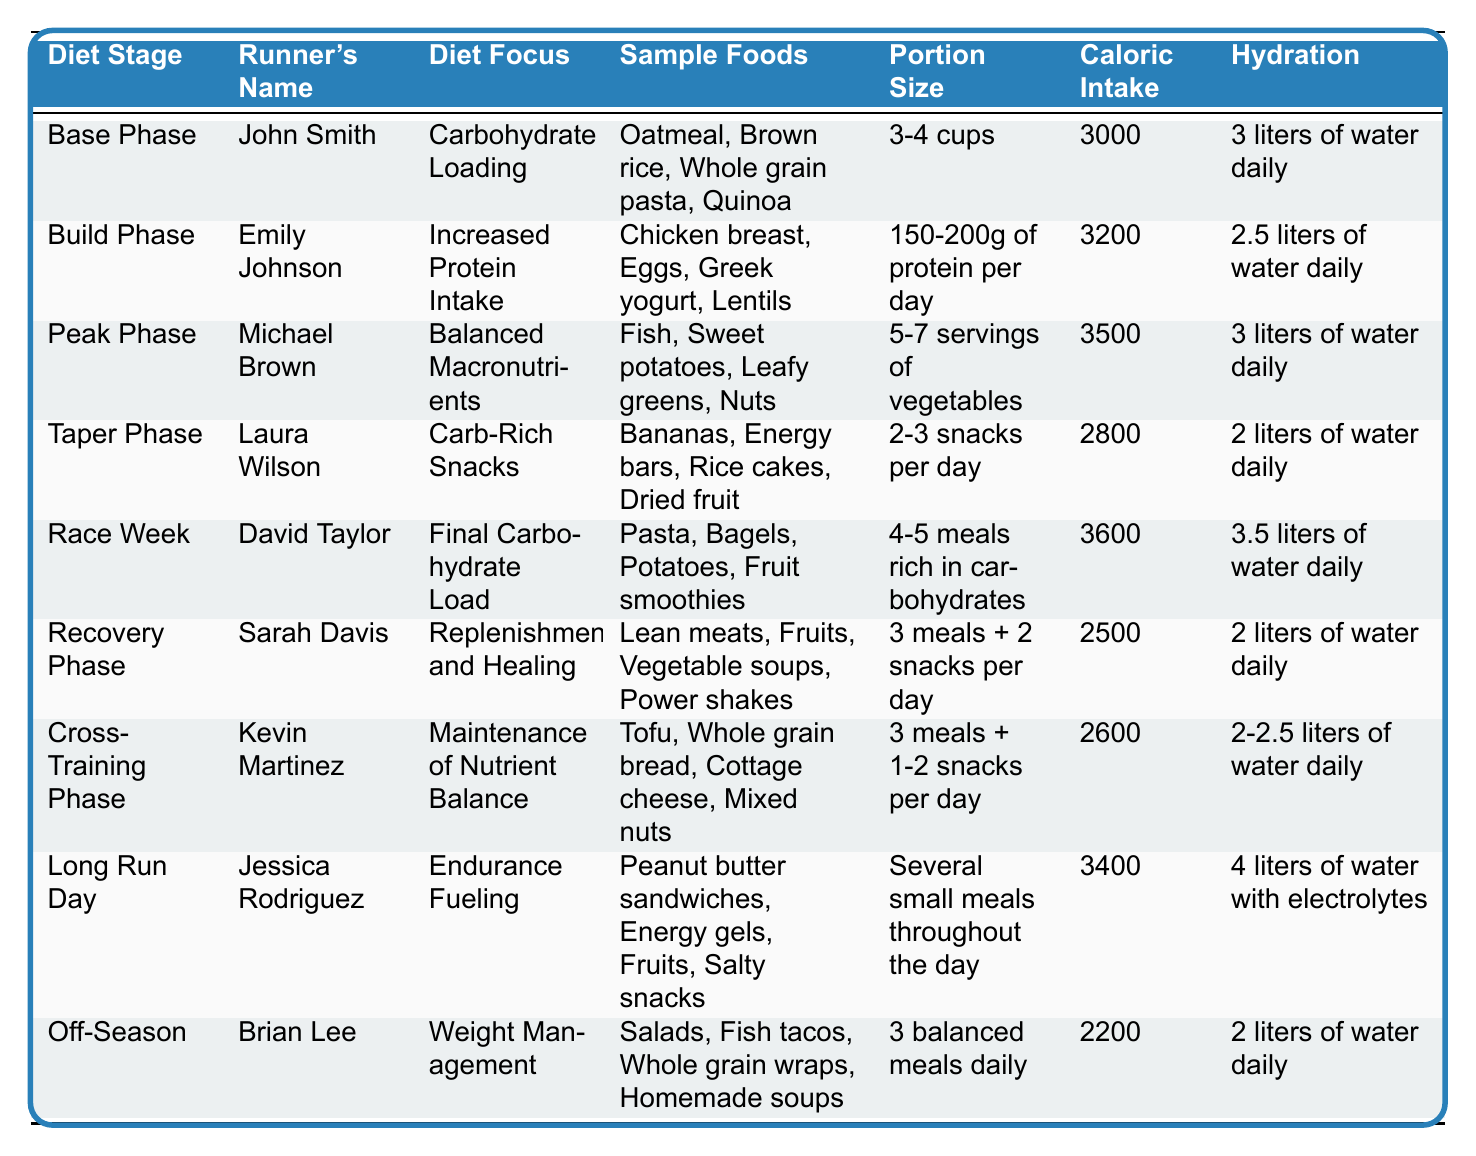What is the diet focus for John Smith during the Base Phase? In the table, under the "DietStage" of "Base Phase," the "DietFocus" listed for "John Smith" is "Carbohydrate Loading."
Answer: Carbohydrate Loading How many liters of water does Sarah Davis consume daily during the Recovery Phase? The table indicates that "Sarah Davis" consumes "2 liters of water daily" during the "Recovery Phase."
Answer: 2 liters What is the total caloric intake proposed for the Peak Phase? Under "Peak Phase," the table shows a "Caloric Intake" of 3500 calories.
Answer: 3500 calories Which runner focuses on maintenance of nutrient balance? The table shows that "Kevin Martinez" is in the "Cross-Training Phase," focusing on "Maintenance of Nutrient Balance."
Answer: Kevin Martinez Is the portion size for Laura Wilson’s snacks greater than or equal to the recommended portion size for John Smith? Laura Wilson's "Portion Size" is "2-3 snacks per day" while John Smith's is "3-4 cups," which is larger in total volume. Therefore, the statement is false.
Answer: No What is the difference in caloric intake between the Race Week and Recovery Phase? The "Race Week" caloric intake is 3600, and the "Recovery Phase" is 2500. The difference is 3600 - 2500 = 1100 calories.
Answer: 1100 calories Which phase has the highest hydration requirement? In the table, the "Race Week" has the highest hydration requirement of "3.5 liters of water daily."
Answer: Race Week Are there any runners whose caloric intake is lower than 2500? In reviewing the table, the lowest caloric intake mentioned is for the "Recovery Phase" at 2500, ensuring that none of the runners have a caloric intake lower than this amount. Thus the answer is no.
Answer: No What is the cumulative caloric intake for all diet stages listed in the table? Summing the caloric intakes gives: 3000 + 3200 + 3500 + 2800 + 3600 + 2500 + 2600 + 3400 + 2200 =  2 + 3 + 3 + 2 + 3 + 2 = 25, the total is 25,000 calories.
Answer: 25,000 calories Which runner has the most varied sample foods? Analyzing the sample foods, "Michael Brown" includes four distinct food categories in "Balanced Macronutrients," showing variety compared to others with fewer types.
Answer: Michael Brown What requirements does Jessica Rodriguez have on Long Run Day? The Long Run Day requires "Endurance Fueling" focusing on several small meals throughout the day and a hydration of "4 liters of water with electrolytes."
Answer: Endurance Fueling, 4 liters of water 